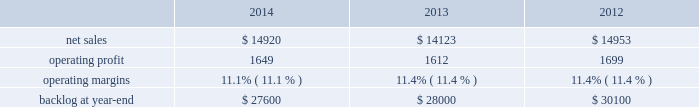2014 , 2013 and 2012 .
The decrease in our consolidated net adjustments for 2014 compared to 2013 was primarily due to a decrease in profit booking rate adjustments at our aeronautics , mfc and mst business segments .
The increase in our consolidated net adjustments for 2013 as compared to 2012 was primarily due to an increase in profit booking rate adjustments at our mst and mfc business segments and , to a lesser extent , the increase in the favorable resolution of contractual matters for the corporation .
The consolidated net adjustments for 2014 are inclusive of approximately $ 650 million in unfavorable items , which include reserves recorded on certain training and logistics solutions programs at mst and net warranty reserve adjustments for various programs ( including jassm and gmlrs ) at mfc as described in the respective business segment 2019s results of operations below .
The consolidated net adjustments for 2013 and 2012 are inclusive of approximately $ 600 million and $ 500 million in unfavorable items , which include a significant profit reduction on the f-35 development contract in both years , as well as a significant profit reduction on the c-5 program in 2013 , each as described in our aeronautics business segment 2019s results of operations discussion below .
Aeronautics our aeronautics business segment is engaged in the research , design , development , manufacture , integration , sustainment , support and upgrade of advanced military aircraft , including combat and air mobility aircraft , unmanned air vehicles and related technologies .
Aeronautics 2019 major programs include the f-35 lightning ii joint strike fighter , c-130 hercules , f-16 fighting falcon , f-22 raptor and the c-5m super galaxy .
Aeronautics 2019 operating results included the following ( in millions ) : .
2014 compared to 2013 aeronautics 2019 net sales for 2014 increased $ 797 million , or 6% ( 6 % ) , compared to 2013 .
The increase was primarily attributable to higher net sales of approximately $ 790 million for f-35 production contracts due to increased volume and sustainment activities ; about $ 55 million for the f-16 program due to increased deliveries ( 17 aircraft delivered in 2014 compared to 13 delivered in 2013 ) partially offset by contract mix ; and approximately $ 45 million for the f-22 program due to increased risk retirements .
The increases were partially offset by lower net sales of approximately $ 55 million for the f-35 development contract due to decreased volume , partially offset by the absence in 2014 of the downward revision to the profit booking rate that occurred in 2013 ; and about $ 40 million for the c-130 program due to fewer deliveries ( 24 aircraft delivered in 2014 compared to 25 delivered in 2013 ) and decreased sustainment activities , partially offset by contract mix .
Aeronautics 2019 operating profit for 2014 increased $ 37 million , or 2% ( 2 % ) , compared to 2013 .
The increase was primarily attributable to higher operating profit of approximately $ 85 million for the f-35 development contract due to the absence in 2014 of the downward revision to the profit booking rate that occurred in 2013 ; about $ 75 million for the f-22 program due to increased risk retirements ; approximately $ 50 million for the c-130 program due to increased risk retirements and contract mix , partially offset by fewer deliveries ; and about $ 25 million for the c-5 program due to the absence in 2014 of the downward revisions to the profit booking rate that occurred in 2013 .
The increases were partially offset by lower operating profit of approximately $ 130 million for the f-16 program due to decreased risk retirements , partially offset by increased deliveries ; and about $ 70 million for sustainment activities due to decreased risk retirements and volume .
Operating profit was comparable for f-35 production contracts as higher volume was offset by lower risk retirements .
Adjustments not related to volume , including net profit booking rate adjustments and other matters , were approximately $ 105 million lower for 2014 compared to 2013 .
2013 compared to 2012 aeronautics 2019 net sales for 2013 decreased $ 830 million , or 6% ( 6 % ) , compared to 2012 .
The decrease was primarily attributable to lower net sales of approximately $ 530 million for the f-16 program due to fewer aircraft deliveries ( 13 aircraft delivered in 2013 compared to 37 delivered in 2012 ) partially offset by aircraft configuration mix ; about $ 385 million for the c-130 program due to fewer aircraft deliveries ( 25 aircraft delivered in 2013 compared to 34 in 2012 ) partially offset by increased sustainment activities ; approximately $ 255 million for the f-22 program , which includes about $ 205 million due to .
What is the growth rate in operating profit for aeronautics in 2014? 
Computations: ((1649 - 1612) / 1612)
Answer: 0.02295. 2014 , 2013 and 2012 .
The decrease in our consolidated net adjustments for 2014 compared to 2013 was primarily due to a decrease in profit booking rate adjustments at our aeronautics , mfc and mst business segments .
The increase in our consolidated net adjustments for 2013 as compared to 2012 was primarily due to an increase in profit booking rate adjustments at our mst and mfc business segments and , to a lesser extent , the increase in the favorable resolution of contractual matters for the corporation .
The consolidated net adjustments for 2014 are inclusive of approximately $ 650 million in unfavorable items , which include reserves recorded on certain training and logistics solutions programs at mst and net warranty reserve adjustments for various programs ( including jassm and gmlrs ) at mfc as described in the respective business segment 2019s results of operations below .
The consolidated net adjustments for 2013 and 2012 are inclusive of approximately $ 600 million and $ 500 million in unfavorable items , which include a significant profit reduction on the f-35 development contract in both years , as well as a significant profit reduction on the c-5 program in 2013 , each as described in our aeronautics business segment 2019s results of operations discussion below .
Aeronautics our aeronautics business segment is engaged in the research , design , development , manufacture , integration , sustainment , support and upgrade of advanced military aircraft , including combat and air mobility aircraft , unmanned air vehicles and related technologies .
Aeronautics 2019 major programs include the f-35 lightning ii joint strike fighter , c-130 hercules , f-16 fighting falcon , f-22 raptor and the c-5m super galaxy .
Aeronautics 2019 operating results included the following ( in millions ) : .
2014 compared to 2013 aeronautics 2019 net sales for 2014 increased $ 797 million , or 6% ( 6 % ) , compared to 2013 .
The increase was primarily attributable to higher net sales of approximately $ 790 million for f-35 production contracts due to increased volume and sustainment activities ; about $ 55 million for the f-16 program due to increased deliveries ( 17 aircraft delivered in 2014 compared to 13 delivered in 2013 ) partially offset by contract mix ; and approximately $ 45 million for the f-22 program due to increased risk retirements .
The increases were partially offset by lower net sales of approximately $ 55 million for the f-35 development contract due to decreased volume , partially offset by the absence in 2014 of the downward revision to the profit booking rate that occurred in 2013 ; and about $ 40 million for the c-130 program due to fewer deliveries ( 24 aircraft delivered in 2014 compared to 25 delivered in 2013 ) and decreased sustainment activities , partially offset by contract mix .
Aeronautics 2019 operating profit for 2014 increased $ 37 million , or 2% ( 2 % ) , compared to 2013 .
The increase was primarily attributable to higher operating profit of approximately $ 85 million for the f-35 development contract due to the absence in 2014 of the downward revision to the profit booking rate that occurred in 2013 ; about $ 75 million for the f-22 program due to increased risk retirements ; approximately $ 50 million for the c-130 program due to increased risk retirements and contract mix , partially offset by fewer deliveries ; and about $ 25 million for the c-5 program due to the absence in 2014 of the downward revisions to the profit booking rate that occurred in 2013 .
The increases were partially offset by lower operating profit of approximately $ 130 million for the f-16 program due to decreased risk retirements , partially offset by increased deliveries ; and about $ 70 million for sustainment activities due to decreased risk retirements and volume .
Operating profit was comparable for f-35 production contracts as higher volume was offset by lower risk retirements .
Adjustments not related to volume , including net profit booking rate adjustments and other matters , were approximately $ 105 million lower for 2014 compared to 2013 .
2013 compared to 2012 aeronautics 2019 net sales for 2013 decreased $ 830 million , or 6% ( 6 % ) , compared to 2012 .
The decrease was primarily attributable to lower net sales of approximately $ 530 million for the f-16 program due to fewer aircraft deliveries ( 13 aircraft delivered in 2013 compared to 37 delivered in 2012 ) partially offset by aircraft configuration mix ; about $ 385 million for the c-130 program due to fewer aircraft deliveries ( 25 aircraft delivered in 2013 compared to 34 in 2012 ) partially offset by increased sustainment activities ; approximately $ 255 million for the f-22 program , which includes about $ 205 million due to .
What was the ratio of the increase in the net sales to the operating profit? 
Computations: (797 / 37)
Answer: 21.54054. 